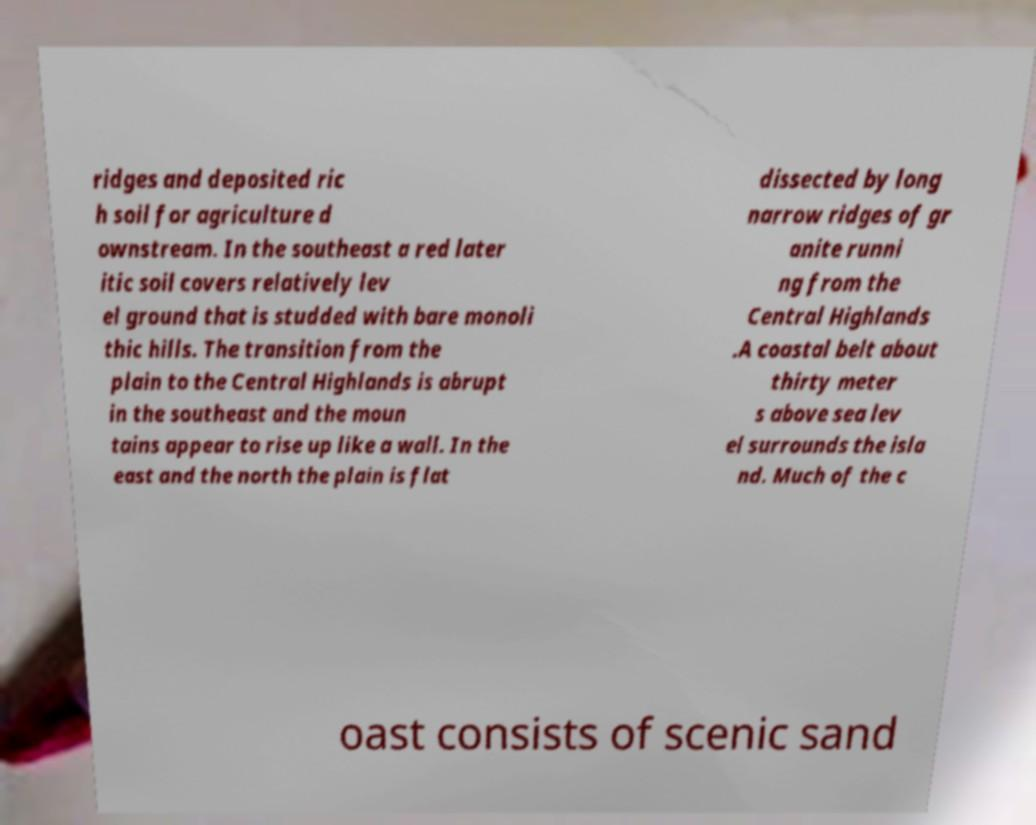Can you accurately transcribe the text from the provided image for me? ridges and deposited ric h soil for agriculture d ownstream. In the southeast a red later itic soil covers relatively lev el ground that is studded with bare monoli thic hills. The transition from the plain to the Central Highlands is abrupt in the southeast and the moun tains appear to rise up like a wall. In the east and the north the plain is flat dissected by long narrow ridges of gr anite runni ng from the Central Highlands .A coastal belt about thirty meter s above sea lev el surrounds the isla nd. Much of the c oast consists of scenic sand 